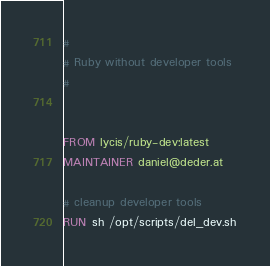<code> <loc_0><loc_0><loc_500><loc_500><_Dockerfile_>#
# Ruby without developer tools
#


FROM lycis/ruby-dev:latest
MAINTAINER daniel@deder.at

# cleanup developer tools
RUN sh /opt/scripts/del_dev.sh
</code> 